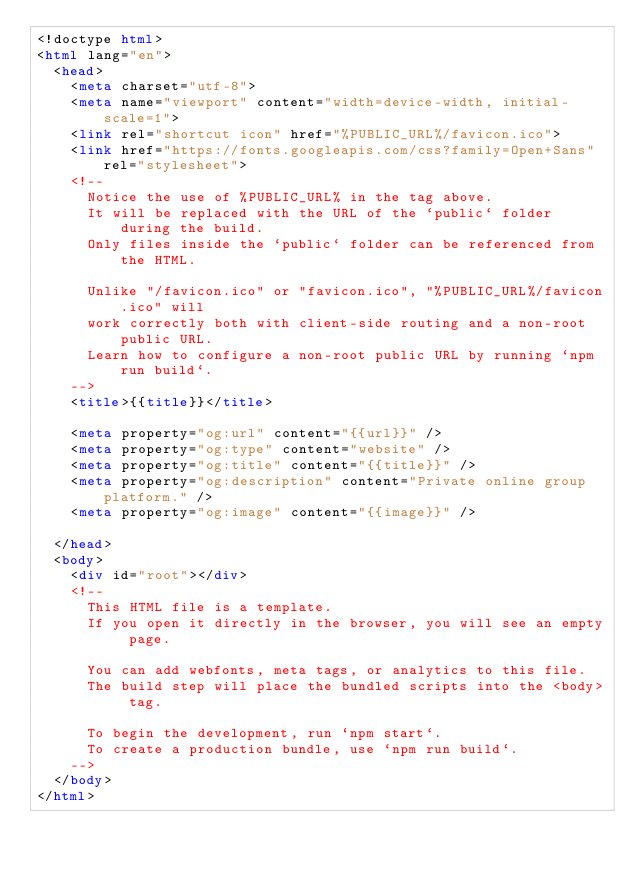<code> <loc_0><loc_0><loc_500><loc_500><_HTML_><!doctype html>
<html lang="en">
  <head>
    <meta charset="utf-8">
    <meta name="viewport" content="width=device-width, initial-scale=1">
    <link rel="shortcut icon" href="%PUBLIC_URL%/favicon.ico">
    <link href="https://fonts.googleapis.com/css?family=Open+Sans" rel="stylesheet">
    <!--
      Notice the use of %PUBLIC_URL% in the tag above.
      It will be replaced with the URL of the `public` folder during the build.
      Only files inside the `public` folder can be referenced from the HTML.

      Unlike "/favicon.ico" or "favicon.ico", "%PUBLIC_URL%/favicon.ico" will
      work correctly both with client-side routing and a non-root public URL.
      Learn how to configure a non-root public URL by running `npm run build`.
    -->
    <title>{{title}}</title>

    <meta property="og:url" content="{{url}}" />
    <meta property="og:type" content="website" />
    <meta property="og:title" content="{{title}}" />
    <meta property="og:description" content="Private online group platform." />
    <meta property="og:image" content="{{image}}" />

  </head>
  <body>
    <div id="root"></div>
    <!--
      This HTML file is a template.
      If you open it directly in the browser, you will see an empty page.

      You can add webfonts, meta tags, or analytics to this file.
      The build step will place the bundled scripts into the <body> tag.

      To begin the development, run `npm start`.
      To create a production bundle, use `npm run build`.
    -->
  </body>
</html>
</code> 